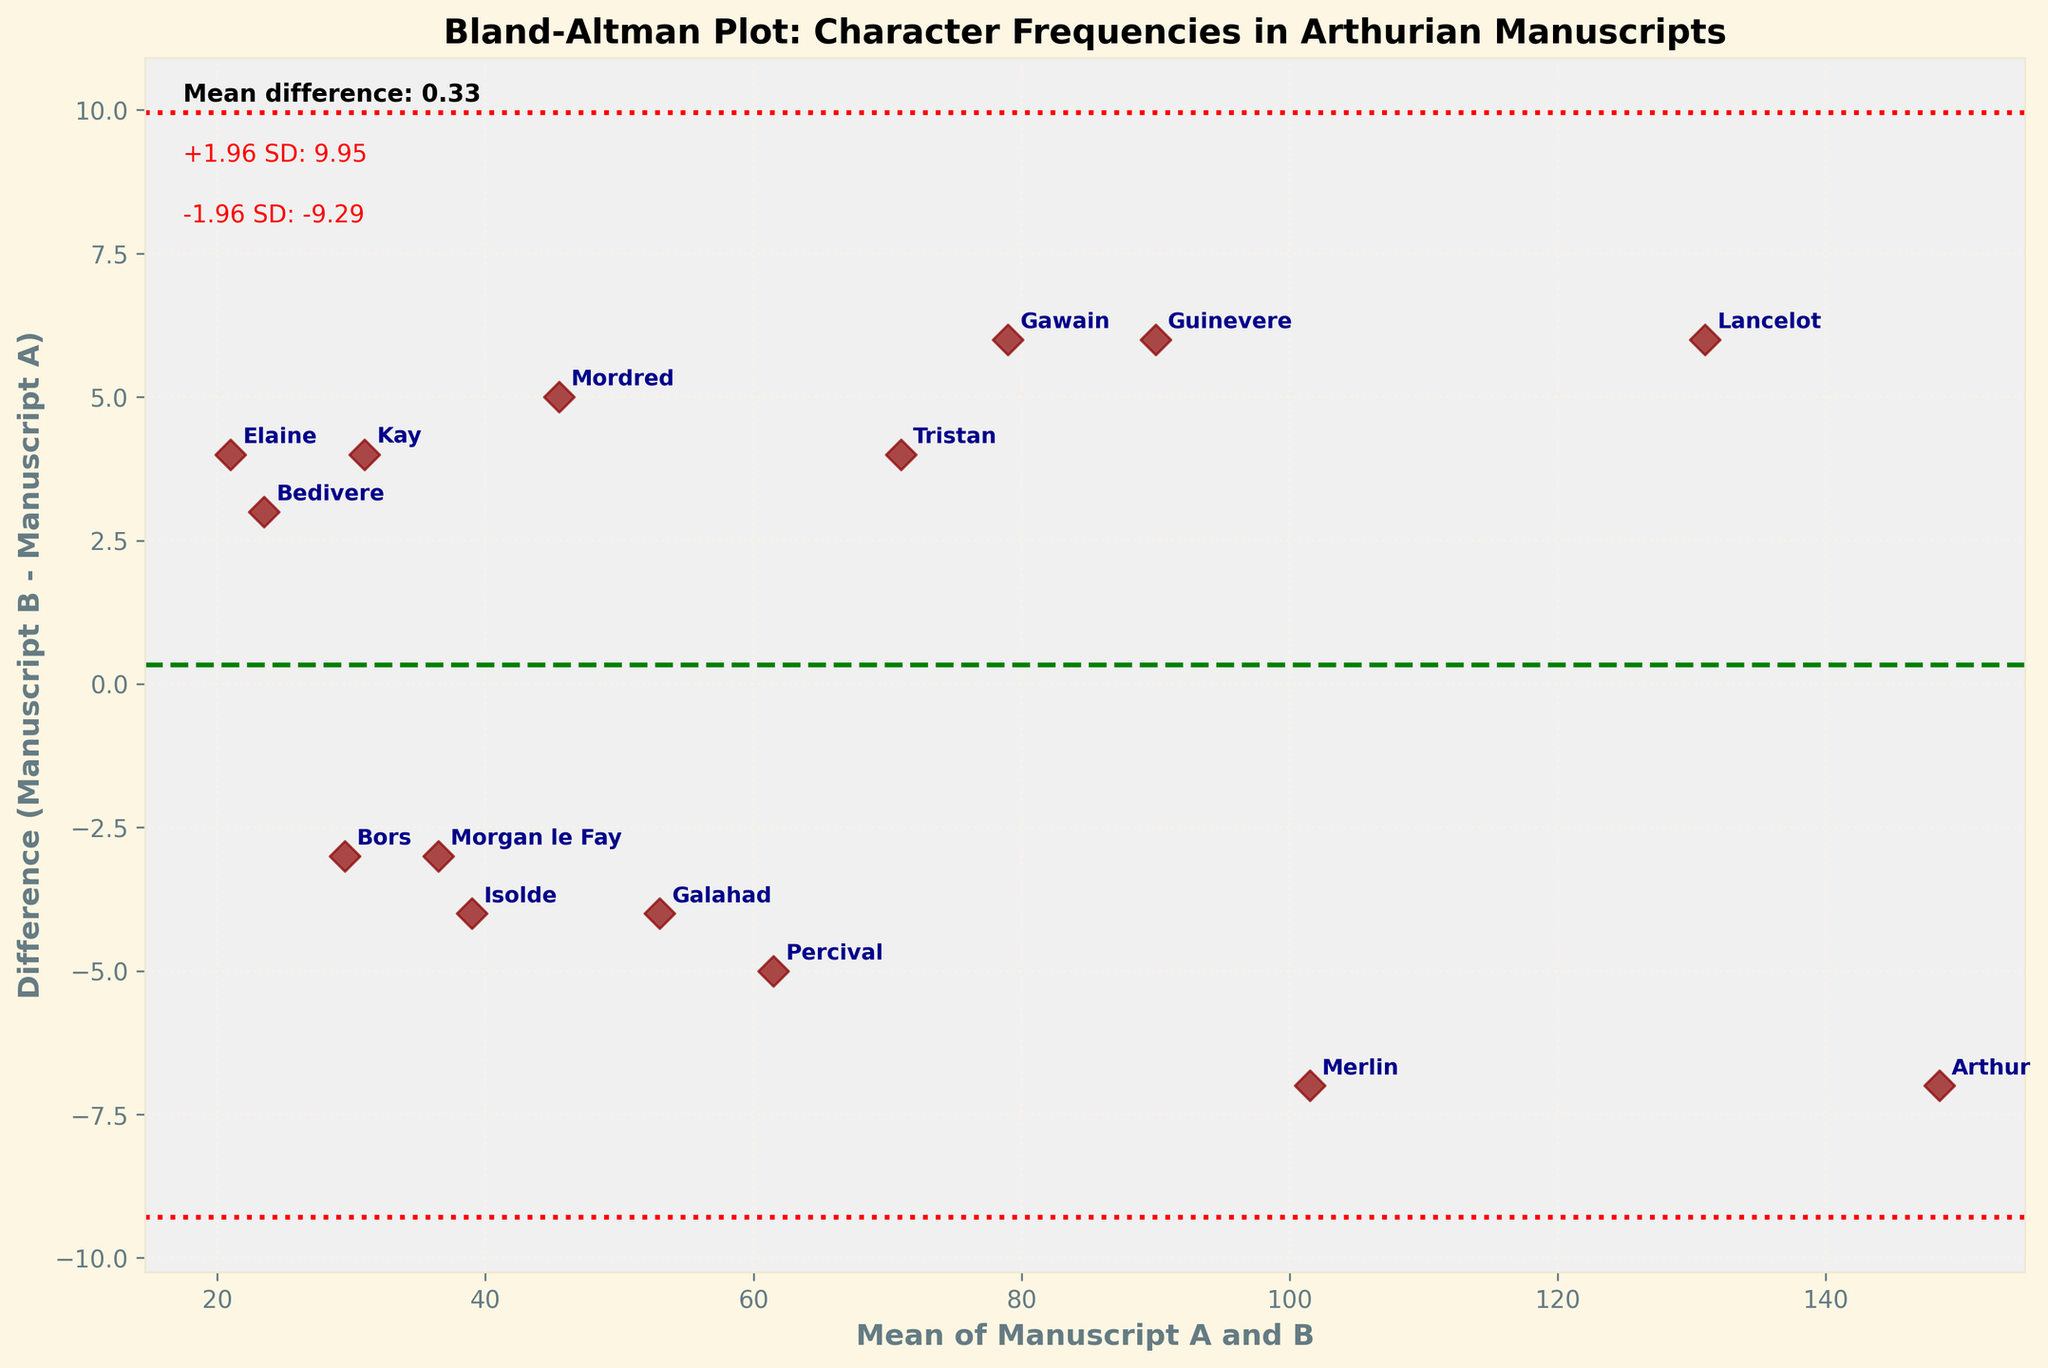How many characters' data points are shown in the plot? Count the number of unique characters displayed on the plot.
Answer: 15 What does the x-axis represent in this plot? Identify the label on the x-axis of the plot. It typically indicates the variable the axis represents.
Answer: Mean of Manuscript A and B What is the mean difference between the manuscripts' character name frequencies? Locate and read the text on the plot that shows the mean difference.
Answer: -1.60 Which character shows the smallest frequency difference between manuscripts A and B? Look for the data point closest to the 0 value on the y-axis (difference). Verify the annotated character next to this point.
Answer: Merlin Which characters' names are more frequently mentioned in Manuscript B than in Manuscript A? Identify the points above the y-axis (difference > 0) and note the corresponding characters.
Answer: Guinevere, Lancelot, Gawain, Mordred, Tristan, Kay, Bedivere, Elaine What are the values of ±1.96 standard deviations from the mean difference? Locate and read the text displaying the ±1.96 SD values from the mean difference line on the plot. Verify the values labeled in red.
Answer: +1.96 SD: 12.75 and -1.96 SD: -15.94 Is “Arthur” mentioned more frequently in Manuscript A or B? What is the difference? Locate the “Arthur” data point and determine if it is above or below the 0 line on the y-axis (difference).
Answer: Manuscript A; Difference is -7 (B - A = 145 - 152) Do more characters fall within the ±1.96 SD bounds or outside of it? Count and compare the number of points within the ±1.96 SD lines and those outside the lines.
Answer: More characters are within the bounds Which character has the greatest difference in mention frequency between the two manuscripts? Identify the point farthest from the 0 line on the y-axis (difference) and note the corresponding character annotation.
Answer: Elaine What does a negative value on the y-axis indicate regarding character mentions in Manuscripts A and B? Interpret the significance of a negative difference value on the Bland–Altman plot’s y-axis.
Answer: Manuscript A has more mentions for that character Which character's name mean frequency lies closest to 100? Find the mean value closest to 100 on the x-axis and identify the character annotated at that position.
Answer: Merlin Is there a trend that suggests one manuscript consistently mentions more characters than the other? Compare the count of points above and below the y=0 line to infer a trend about which manuscript tends to mention more characters overall.
Answer: No clear trend; mixed mentions 